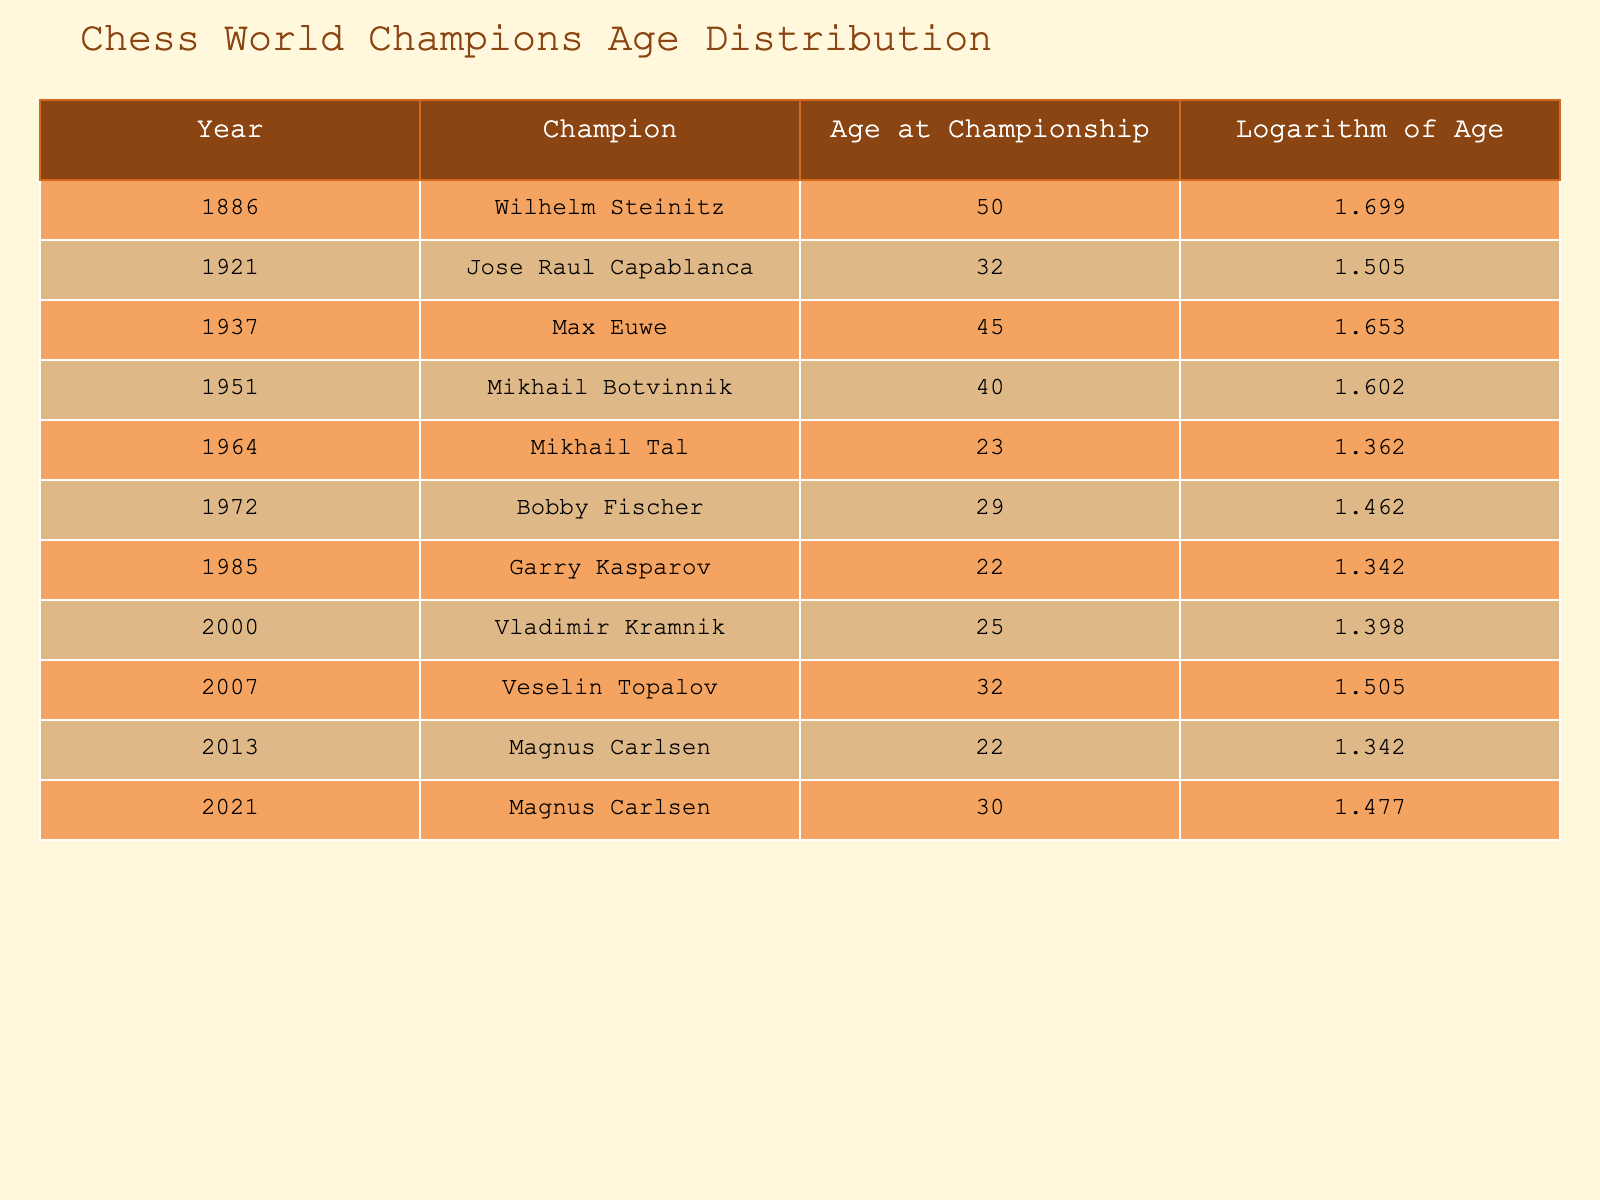What was the age of Bobby Fischer when he won the championship? The table indicates that Bobby Fischer won the championship in 1972 and his age at that time was 29.
Answer: 29 Which champion had the highest age at the time of winning? By examining the ages listed in the table, Wilhelm Steinitz was 50 years old when he won in 1886, which is the highest age among all champions listed.
Answer: 50 Is Mikhail Tal the youngest player to win the championship? The table shows that Mikhail Tal was 23 years old when he won in 1964. Both Garry Kasparov and Magnus Carlsen were also 22 years old when they won. Therefore, Mikhail Tal is not the youngest as there are others who were younger.
Answer: No What is the average age of the champions listed in the table? To find the average age, we first sum all ages: 50 + 32 + 45 + 40 + 23 + 29 + 22 + 25 + 32 + 22 + 30 =  354. There are 11 data points, so we divide 354 by 11, which gives us an average of approximately 32.18.
Answer: 32.18 How many champions were under the age of 30 when they won? From the table, we see that Mikhail Tal (23), Garry Kasparov (22), and Magnus Carlsen (22) were under 30 when they won. That makes a total of 3 champions under the age of 30.
Answer: 3 What is the difference in age between the youngest and the oldest champion? The oldest champion is Wilhelm Steinitz at 50 years and the youngest champions are Garry Kasparov and Magnus Carlsen at 22 years. The difference in age is 50 - 22 = 28.
Answer: 28 Was the logarithm of age of Mikhail Tal greater than that of Bobby Fischer? The logarithm of Mikhail Tal's age when he won was 1.362, while Bobby Fischer's logarithm was 1.462. Therefore, Mikhail Tal's logarithm is not greater.
Answer: No How many years separated the championships won by Garry Kasparov and Vladimir Kramnik? Garry Kasparov won in 1985 and Vladimir Kramnik won in 2000. Subtracting the years gives us 2000 - 1985 = 15 years between their championships.
Answer: 15 